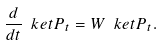Convert formula to latex. <formula><loc_0><loc_0><loc_500><loc_500>\frac { d } { d t } \ k e t { P _ { t } } = W \ k e t { P _ { t } } .</formula> 